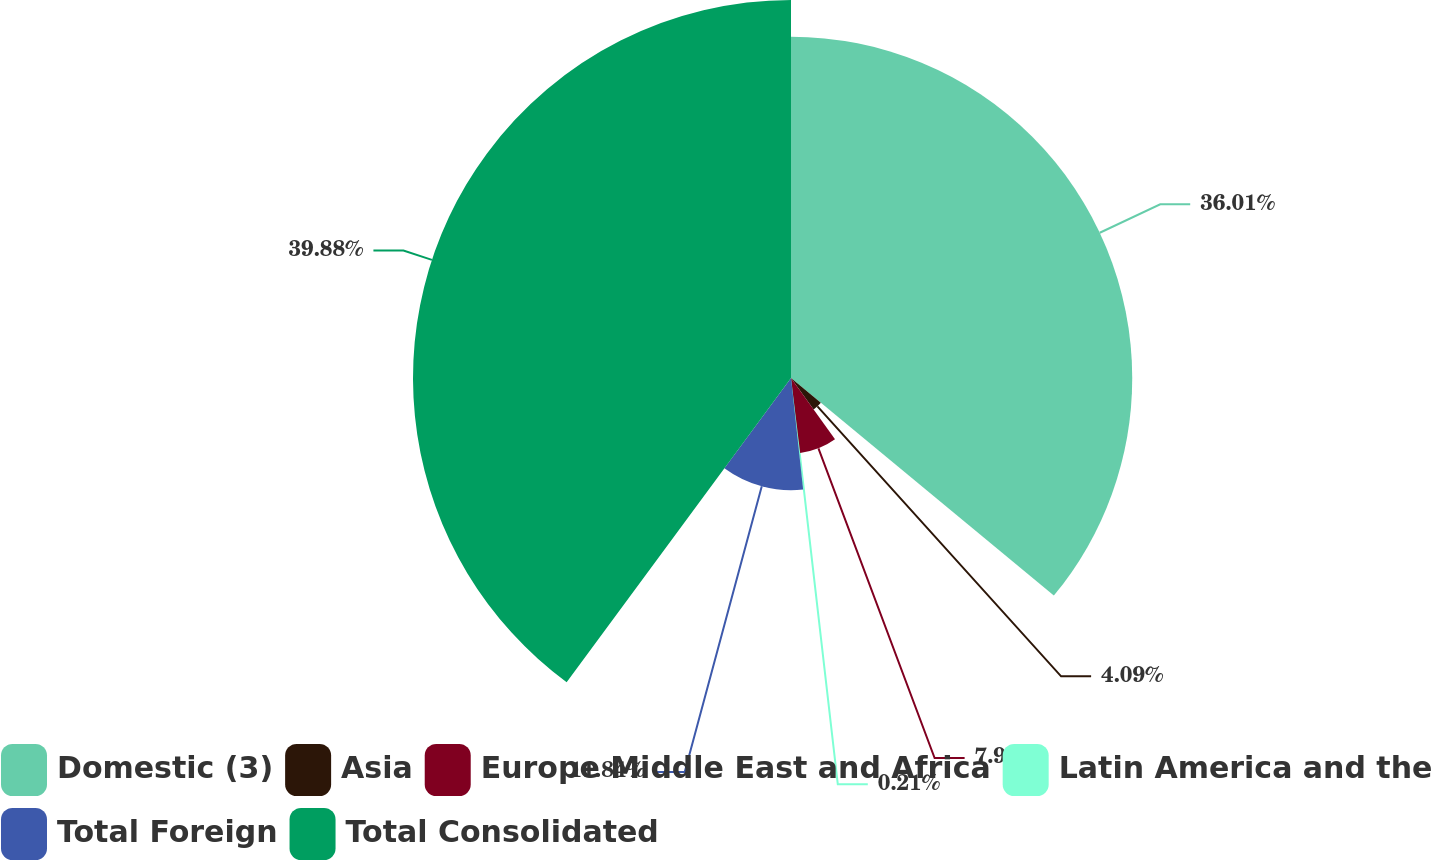<chart> <loc_0><loc_0><loc_500><loc_500><pie_chart><fcel>Domestic (3)<fcel>Asia<fcel>Europe Middle East and Africa<fcel>Latin America and the<fcel>Total Foreign<fcel>Total Consolidated<nl><fcel>36.01%<fcel>4.09%<fcel>7.97%<fcel>0.21%<fcel>11.84%<fcel>39.89%<nl></chart> 